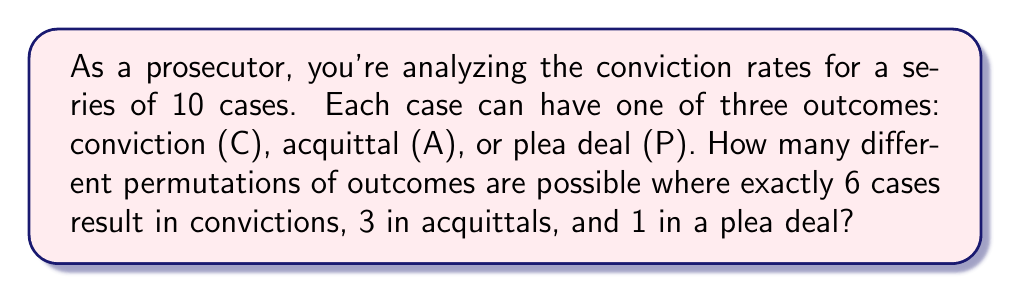Give your solution to this math problem. Let's approach this step-by-step:

1) We have 10 cases in total, and we need to arrange them in a specific order with:
   - 6 convictions (C)
   - 3 acquittals (A)
   - 1 plea deal (P)

2) This is a permutation problem where the order matters (as we're looking at different arrangements), but we have repeated elements (multiple Cs and As).

3) The formula for permutations with repetition is:

   $$\frac{n!}{n_1! \cdot n_2! \cdot ... \cdot n_k!}$$

   Where:
   - $n$ is the total number of items
   - $n_1, n_2, ..., n_k$ are the numbers of each type of item

4) In our case:
   - $n = 10$ (total cases)
   - $n_1 = 6$ (convictions)
   - $n_2 = 3$ (acquittals)
   - $n_3 = 1$ (plea deal)

5) Plugging these into our formula:

   $$\frac{10!}{6! \cdot 3! \cdot 1!}$$

6) Let's calculate this:
   
   $$\frac{10 \cdot 9 \cdot 8 \cdot 7 \cdot 6!}{6! \cdot 3 \cdot 2 \cdot 1 \cdot 1}$$

7) The 6! cancels out in the numerator and denominator:

   $$\frac{10 \cdot 9 \cdot 8 \cdot 7}{3 \cdot 2 \cdot 1} = \frac{5040}{6} = 840$$

Therefore, there are 840 different permutations of outcomes possible.
Answer: 840 permutations 